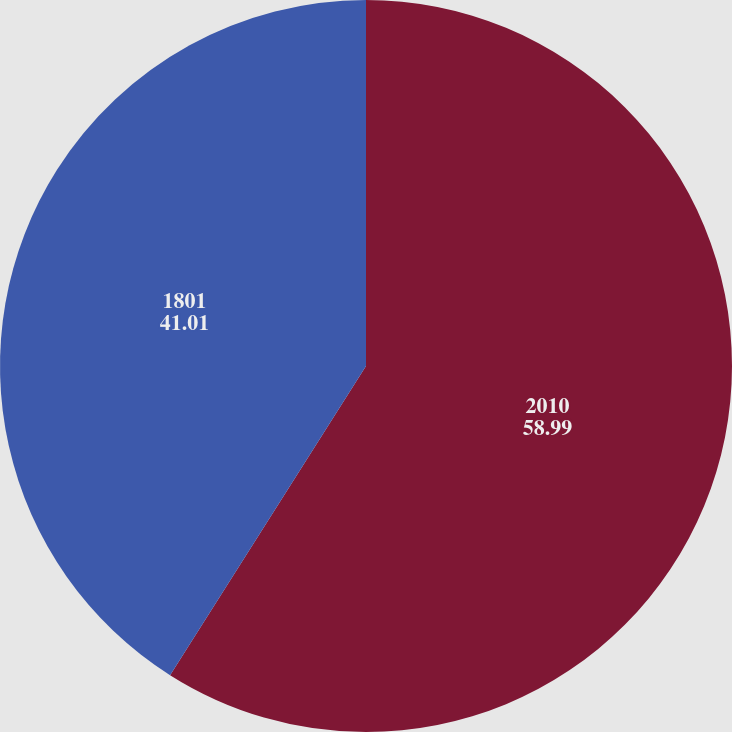Convert chart to OTSL. <chart><loc_0><loc_0><loc_500><loc_500><pie_chart><fcel>2010<fcel>1801<nl><fcel>58.99%<fcel>41.01%<nl></chart> 